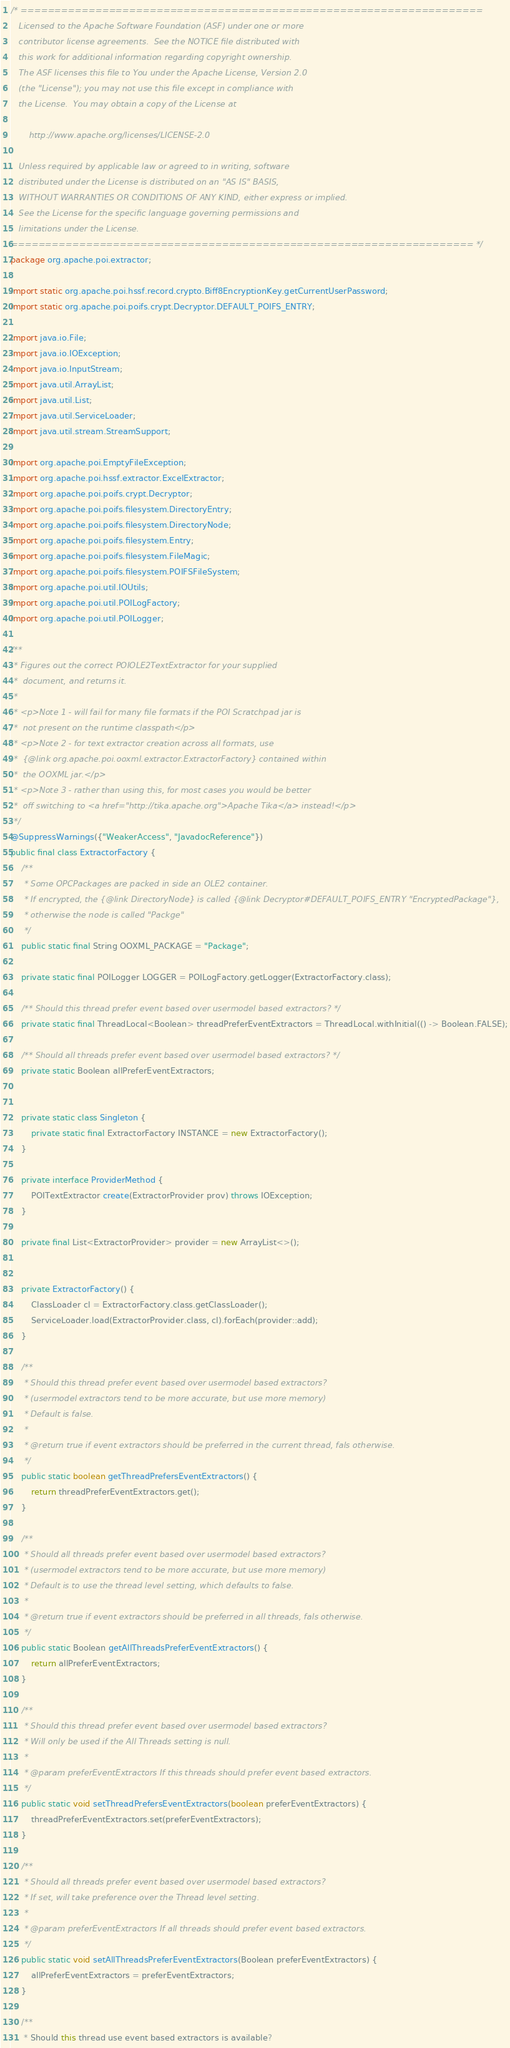<code> <loc_0><loc_0><loc_500><loc_500><_Java_>/* ====================================================================
   Licensed to the Apache Software Foundation (ASF) under one or more
   contributor license agreements.  See the NOTICE file distributed with
   this work for additional information regarding copyright ownership.
   The ASF licenses this file to You under the Apache License, Version 2.0
   (the "License"); you may not use this file except in compliance with
   the License.  You may obtain a copy of the License at

       http://www.apache.org/licenses/LICENSE-2.0

   Unless required by applicable law or agreed to in writing, software
   distributed under the License is distributed on an "AS IS" BASIS,
   WITHOUT WARRANTIES OR CONDITIONS OF ANY KIND, either express or implied.
   See the License for the specific language governing permissions and
   limitations under the License.
==================================================================== */
package org.apache.poi.extractor;

import static org.apache.poi.hssf.record.crypto.Biff8EncryptionKey.getCurrentUserPassword;
import static org.apache.poi.poifs.crypt.Decryptor.DEFAULT_POIFS_ENTRY;

import java.io.File;
import java.io.IOException;
import java.io.InputStream;
import java.util.ArrayList;
import java.util.List;
import java.util.ServiceLoader;
import java.util.stream.StreamSupport;

import org.apache.poi.EmptyFileException;
import org.apache.poi.hssf.extractor.ExcelExtractor;
import org.apache.poi.poifs.crypt.Decryptor;
import org.apache.poi.poifs.filesystem.DirectoryEntry;
import org.apache.poi.poifs.filesystem.DirectoryNode;
import org.apache.poi.poifs.filesystem.Entry;
import org.apache.poi.poifs.filesystem.FileMagic;
import org.apache.poi.poifs.filesystem.POIFSFileSystem;
import org.apache.poi.util.IOUtils;
import org.apache.poi.util.POILogFactory;
import org.apache.poi.util.POILogger;

/**
 * Figures out the correct POIOLE2TextExtractor for your supplied
 *  document, and returns it.
 *
 * <p>Note 1 - will fail for many file formats if the POI Scratchpad jar is
 *  not present on the runtime classpath</p>
 * <p>Note 2 - for text extractor creation across all formats, use
 *  {@link org.apache.poi.ooxml.extractor.ExtractorFactory} contained within
 *  the OOXML jar.</p>
 * <p>Note 3 - rather than using this, for most cases you would be better
 *  off switching to <a href="http://tika.apache.org">Apache Tika</a> instead!</p>
 */
@SuppressWarnings({"WeakerAccess", "JavadocReference"})
public final class ExtractorFactory {
    /**
     * Some OPCPackages are packed in side an OLE2 container.
     * If encrypted, the {@link DirectoryNode} is called {@link Decryptor#DEFAULT_POIFS_ENTRY "EncryptedPackage"},
     * otherwise the node is called "Packge"
     */
    public static final String OOXML_PACKAGE = "Package";

    private static final POILogger LOGGER = POILogFactory.getLogger(ExtractorFactory.class);

    /** Should this thread prefer event based over usermodel based extractors? */
    private static final ThreadLocal<Boolean> threadPreferEventExtractors = ThreadLocal.withInitial(() -> Boolean.FALSE);

    /** Should all threads prefer event based over usermodel based extractors? */
    private static Boolean allPreferEventExtractors;


    private static class Singleton {
        private static final ExtractorFactory INSTANCE = new ExtractorFactory();
    }

    private interface ProviderMethod {
        POITextExtractor create(ExtractorProvider prov) throws IOException;
    }

    private final List<ExtractorProvider> provider = new ArrayList<>();


    private ExtractorFactory() {
        ClassLoader cl = ExtractorFactory.class.getClassLoader();
        ServiceLoader.load(ExtractorProvider.class, cl).forEach(provider::add);
    }

    /**
     * Should this thread prefer event based over usermodel based extractors?
     * (usermodel extractors tend to be more accurate, but use more memory)
     * Default is false.
     *
     * @return true if event extractors should be preferred in the current thread, fals otherwise.
     */
    public static boolean getThreadPrefersEventExtractors() {
        return threadPreferEventExtractors.get();
    }

    /**
     * Should all threads prefer event based over usermodel based extractors?
     * (usermodel extractors tend to be more accurate, but use more memory)
     * Default is to use the thread level setting, which defaults to false.
     *
     * @return true if event extractors should be preferred in all threads, fals otherwise.
     */
    public static Boolean getAllThreadsPreferEventExtractors() {
        return allPreferEventExtractors;
    }

    /**
     * Should this thread prefer event based over usermodel based extractors?
     * Will only be used if the All Threads setting is null.
     *
     * @param preferEventExtractors If this threads should prefer event based extractors.
     */
    public static void setThreadPrefersEventExtractors(boolean preferEventExtractors) {
        threadPreferEventExtractors.set(preferEventExtractors);
    }

    /**
     * Should all threads prefer event based over usermodel based extractors?
     * If set, will take preference over the Thread level setting.
     *
     * @param preferEventExtractors If all threads should prefer event based extractors.
     */
    public static void setAllThreadsPreferEventExtractors(Boolean preferEventExtractors) {
        allPreferEventExtractors = preferEventExtractors;
    }

    /**
     * Should this thread use event based extractors is available?</code> 